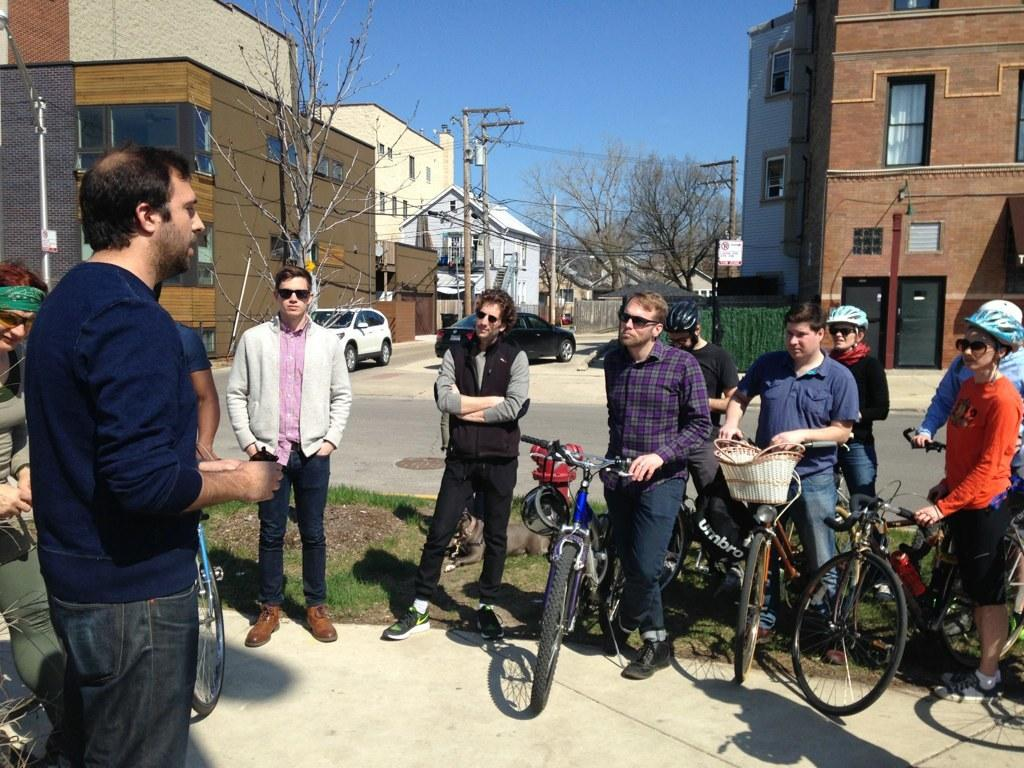What are the people in the image doing? The people in the image are standing. What are some people holding in the image? Some people have cycles in the image. What can be seen in the background of the image? In the background, there is a road, 2 cars, buildings, trees, poles, and the sky. What type of creature can be seen swimming in the channel in the image? There is no channel or creature present in the image. How much salt is visible on the poles in the image? There is no salt visible on the poles in the image. 